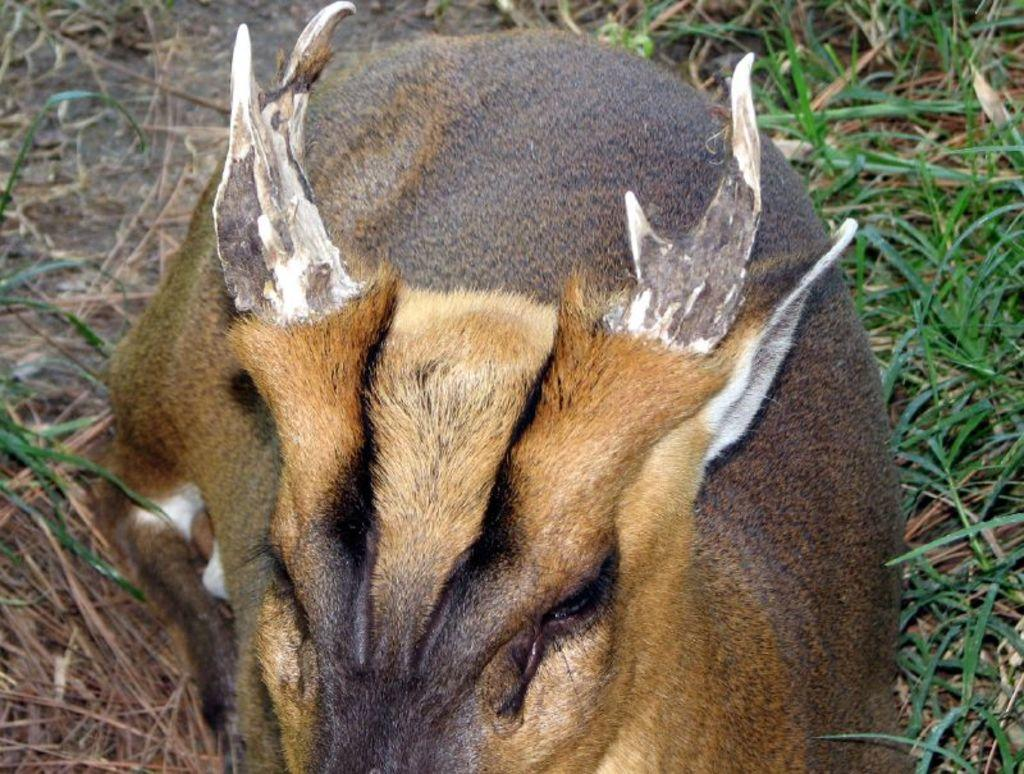What type of animal is in the image? The facts provided do not specify the type of animal in the image. Where is the animal located in the image? The animal is in the foreground of the image. What type of natural environment is visible in the image? There is grass visible in the image. What type of breakfast is the animal requesting in the image? There is no indication in the image that the animal is requesting any type of breakfast. 